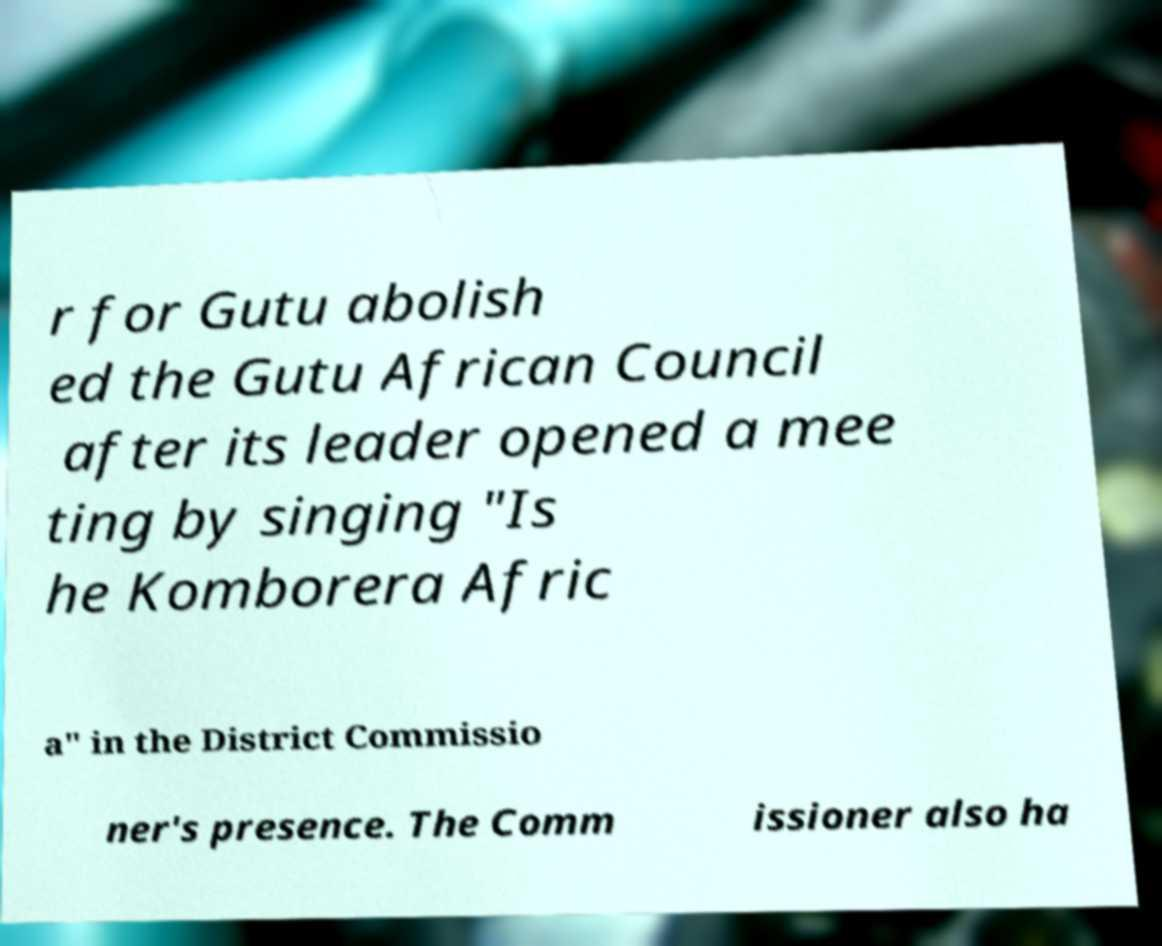Could you extract and type out the text from this image? r for Gutu abolish ed the Gutu African Council after its leader opened a mee ting by singing "Is he Komborera Afric a" in the District Commissio ner's presence. The Comm issioner also ha 